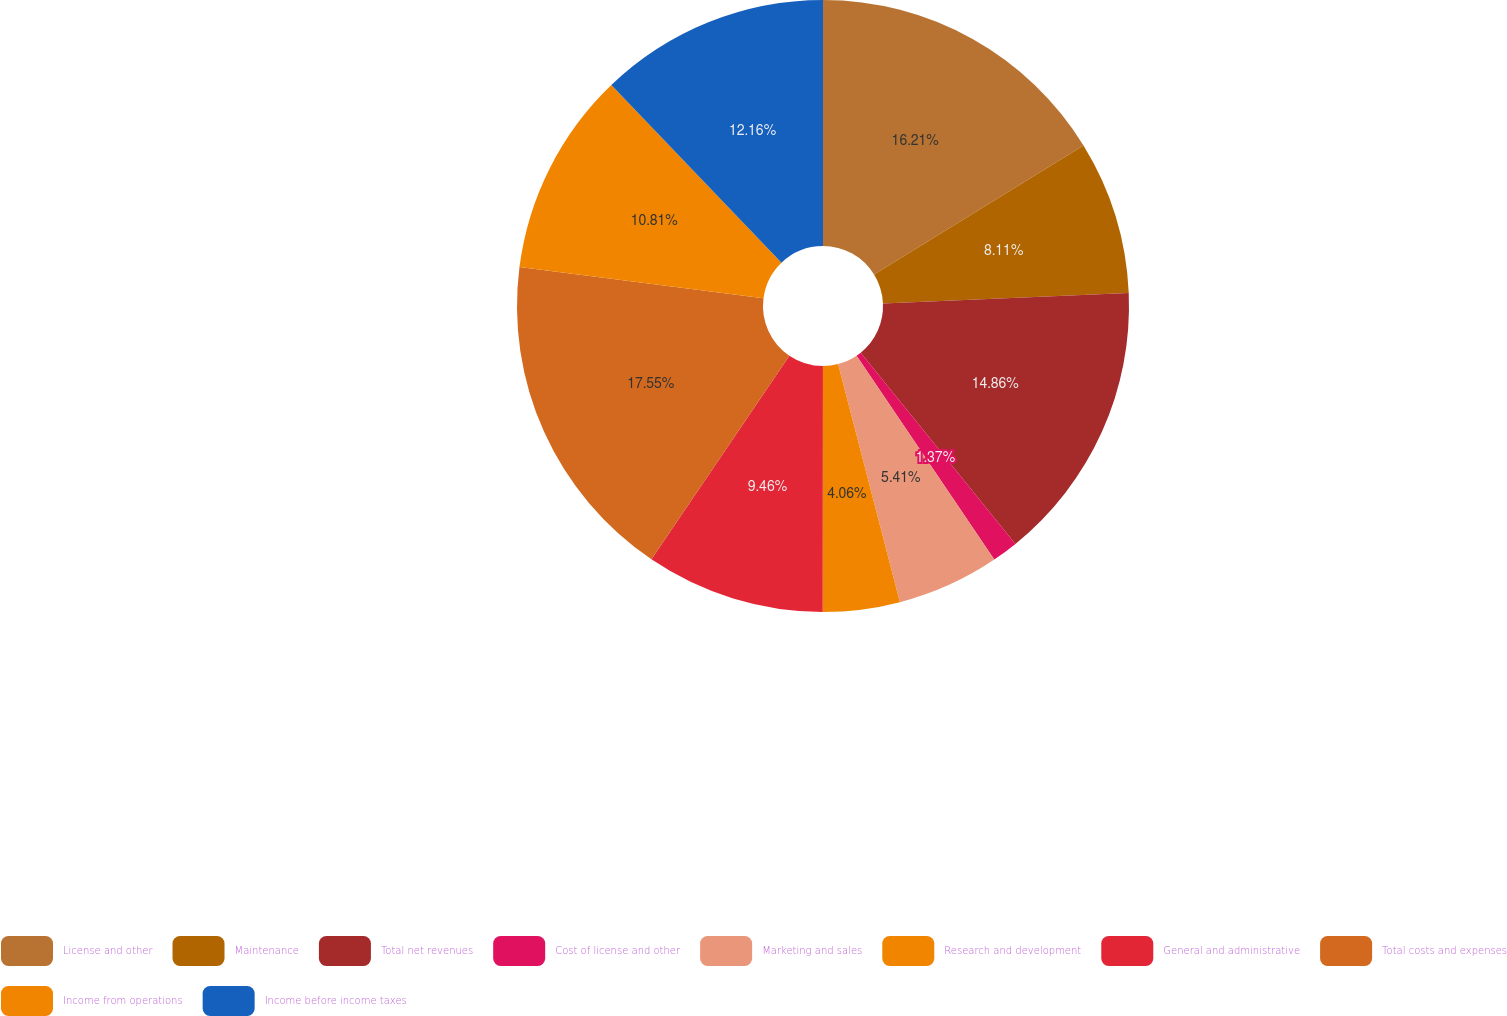<chart> <loc_0><loc_0><loc_500><loc_500><pie_chart><fcel>License and other<fcel>Maintenance<fcel>Total net revenues<fcel>Cost of license and other<fcel>Marketing and sales<fcel>Research and development<fcel>General and administrative<fcel>Total costs and expenses<fcel>Income from operations<fcel>Income before income taxes<nl><fcel>16.21%<fcel>8.11%<fcel>14.86%<fcel>1.37%<fcel>5.41%<fcel>4.06%<fcel>9.46%<fcel>17.56%<fcel>10.81%<fcel>12.16%<nl></chart> 